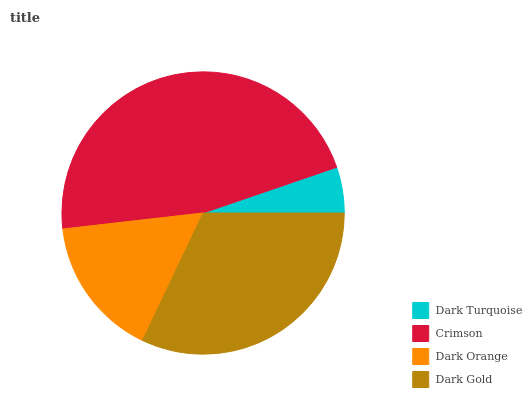Is Dark Turquoise the minimum?
Answer yes or no. Yes. Is Crimson the maximum?
Answer yes or no. Yes. Is Dark Orange the minimum?
Answer yes or no. No. Is Dark Orange the maximum?
Answer yes or no. No. Is Crimson greater than Dark Orange?
Answer yes or no. Yes. Is Dark Orange less than Crimson?
Answer yes or no. Yes. Is Dark Orange greater than Crimson?
Answer yes or no. No. Is Crimson less than Dark Orange?
Answer yes or no. No. Is Dark Gold the high median?
Answer yes or no. Yes. Is Dark Orange the low median?
Answer yes or no. Yes. Is Dark Orange the high median?
Answer yes or no. No. Is Dark Gold the low median?
Answer yes or no. No. 